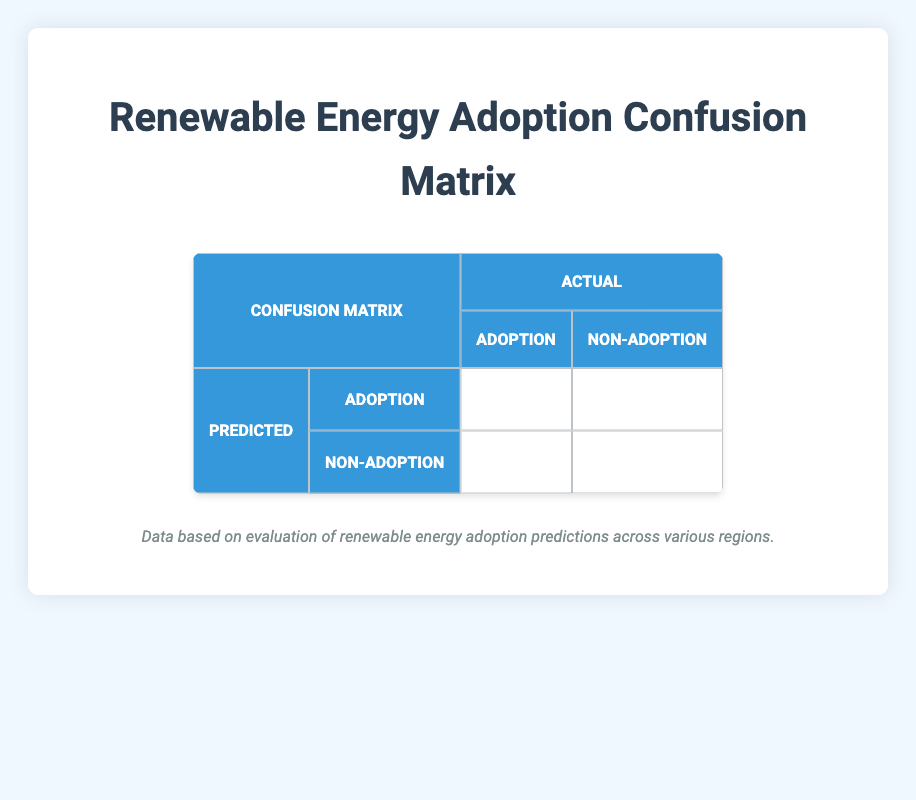What is the number of true positives in the confusion matrix? The true positives in the confusion matrix are represented in the cell where predicted adoption matches actual adoption. According to the table, there are 3 regions where both predicted and actual values are "Adoption."
Answer: 3 How many regions were predicted as "Non-Adoption"? To determine the number of regions predicted as "Non-Adoption," we can count the rows under the "Non-Adoption" prediction in the table. There are 3 regions: Texas, Washington, and Illinois.
Answer: 3 What is the total number of actual "Non-Adoption" cases? We can find this by adding the actual "Non-Adoption" cases in the table. There are 2 cases predicted as "Non-Adoption" that are actually Non-Adoption and 2 cases predicted as "Adoption" that are actually Non-Adoption. Thus, the total is 2 + 2 = 4.
Answer: 4 Is it true that the number of true negatives is equal to the number of regions in which both predicted and actual values are "Non-Adoption"? In the confusion matrix, the true negatives are those cases where both predicted and actual values are "Non-Adoption." There are 2 regions (Michigan and one more from a non-adoption prediction) that fit this criterion, so the statement is true.
Answer: Yes What is the ratio of false negatives to false positives? To find the ratio, we obtain the counts from the matrix. There is 1 false negative and 2 false positives, giving us a ratio of 1:2 (1 false negative to 2 false positives).
Answer: 1:2 What is the overall accuracy of the prediction model? Overall accuracy can be calculated as (True Positives + True Negatives) / Total Number of Cases. Here, it’s (3 + 2) / 8 = 5/8, which simplifies to 0.625 or 62.5%.
Answer: 62.5% How many regions faced a misclassification (either False Positive or False Negative)? A region is misclassified if it is either a false positive or a false negative. According to the confusion matrix, there are 2 false positives (Texas and Illinois) and 1 false negative (Washington), totaling 2 + 1 = 3 misclassified regions.
Answer: 3 What percentage of the total cases were correctly classified? To find the percentage of correctly classified cases, we can determine the number of correct classifications (3 true positives + 2 true negatives = 5) out of the total (8 regions). The calculation is (5/8) * 100 = 62.5%.
Answer: 62.5% What is the number of regions where both the predicted and actual outcomes were "Adoption"? We look at the "Adoption" predicted that coincides with the "Adoption" actual in the table. There are 3 such regions: California, Florida, and Oregon.
Answer: 3 